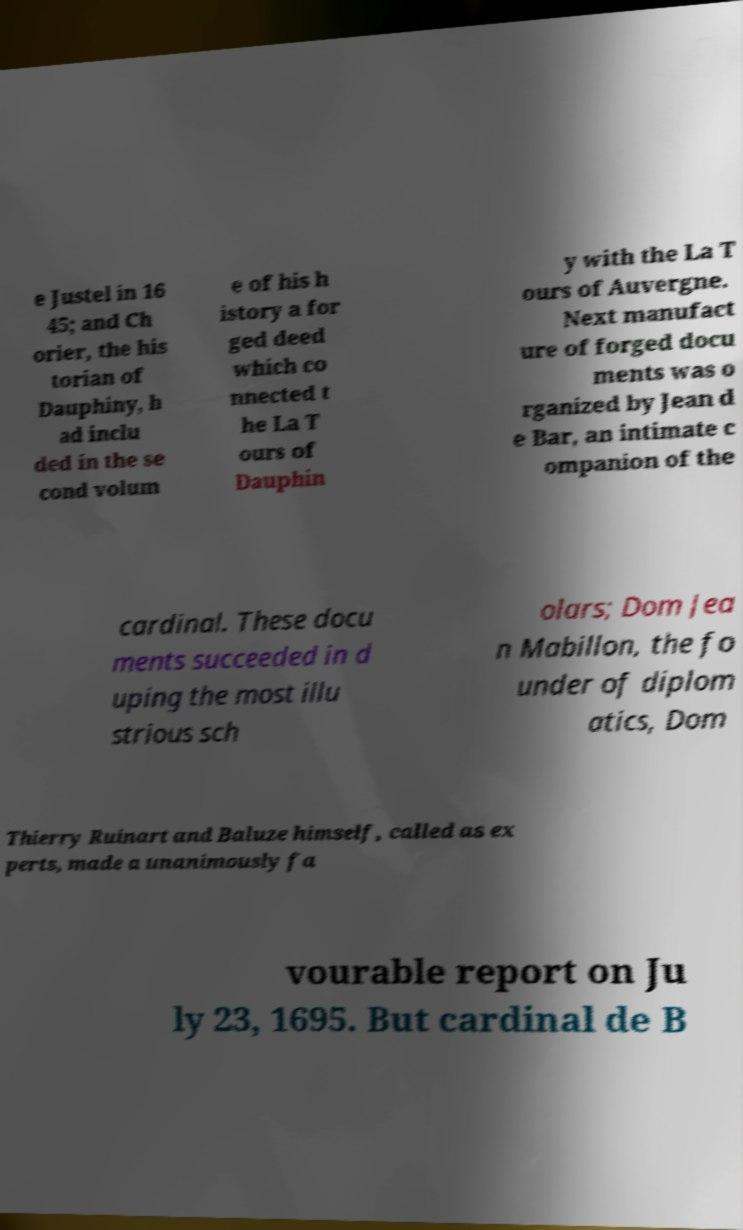There's text embedded in this image that I need extracted. Can you transcribe it verbatim? e Justel in 16 45; and Ch orier, the his torian of Dauphiny, h ad inclu ded in the se cond volum e of his h istory a for ged deed which co nnected t he La T ours of Dauphin y with the La T ours of Auvergne. Next manufact ure of forged docu ments was o rganized by Jean d e Bar, an intimate c ompanion of the cardinal. These docu ments succeeded in d uping the most illu strious sch olars; Dom Jea n Mabillon, the fo under of diplom atics, Dom Thierry Ruinart and Baluze himself, called as ex perts, made a unanimously fa vourable report on Ju ly 23, 1695. But cardinal de B 